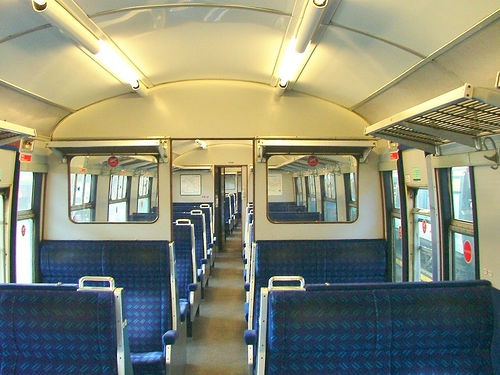Describe the objects in this image and their specific colors. I can see train in khaki, darkblue, darkgray, tan, and blue tones, bench in tan, darkblue, navy, blue, and darkgray tones, bench in tan, navy, blue, and black tones, bench in tan, navy, blue, and darkblue tones, and bench in tan, darkblue, black, and blue tones in this image. 